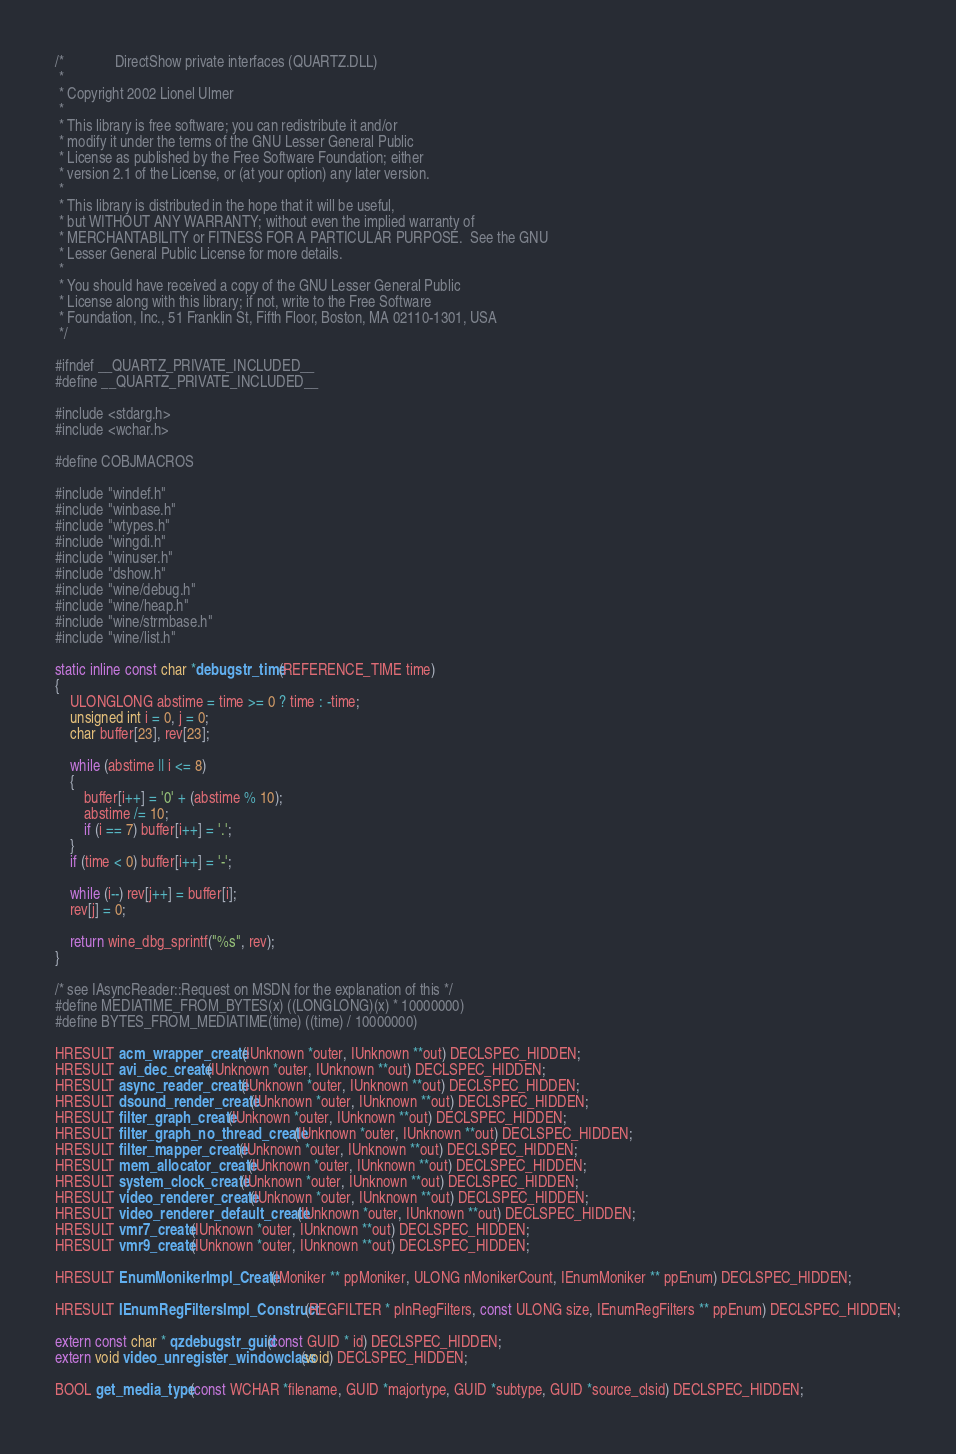Convert code to text. <code><loc_0><loc_0><loc_500><loc_500><_C_>/*              DirectShow private interfaces (QUARTZ.DLL)
 *
 * Copyright 2002 Lionel Ulmer
 *
 * This library is free software; you can redistribute it and/or
 * modify it under the terms of the GNU Lesser General Public
 * License as published by the Free Software Foundation; either
 * version 2.1 of the License, or (at your option) any later version.
 *
 * This library is distributed in the hope that it will be useful,
 * but WITHOUT ANY WARRANTY; without even the implied warranty of
 * MERCHANTABILITY or FITNESS FOR A PARTICULAR PURPOSE.  See the GNU
 * Lesser General Public License for more details.
 *
 * You should have received a copy of the GNU Lesser General Public
 * License along with this library; if not, write to the Free Software
 * Foundation, Inc., 51 Franklin St, Fifth Floor, Boston, MA 02110-1301, USA
 */

#ifndef __QUARTZ_PRIVATE_INCLUDED__
#define __QUARTZ_PRIVATE_INCLUDED__

#include <stdarg.h>
#include <wchar.h>

#define COBJMACROS

#include "windef.h"
#include "winbase.h"
#include "wtypes.h"
#include "wingdi.h"
#include "winuser.h"
#include "dshow.h"
#include "wine/debug.h"
#include "wine/heap.h"
#include "wine/strmbase.h"
#include "wine/list.h"

static inline const char *debugstr_time(REFERENCE_TIME time)
{
    ULONGLONG abstime = time >= 0 ? time : -time;
    unsigned int i = 0, j = 0;
    char buffer[23], rev[23];

    while (abstime || i <= 8)
    {
        buffer[i++] = '0' + (abstime % 10);
        abstime /= 10;
        if (i == 7) buffer[i++] = '.';
    }
    if (time < 0) buffer[i++] = '-';

    while (i--) rev[j++] = buffer[i];
    rev[j] = 0;

    return wine_dbg_sprintf("%s", rev);
}

/* see IAsyncReader::Request on MSDN for the explanation of this */
#define MEDIATIME_FROM_BYTES(x) ((LONGLONG)(x) * 10000000)
#define BYTES_FROM_MEDIATIME(time) ((time) / 10000000)

HRESULT acm_wrapper_create(IUnknown *outer, IUnknown **out) DECLSPEC_HIDDEN;
HRESULT avi_dec_create(IUnknown *outer, IUnknown **out) DECLSPEC_HIDDEN;
HRESULT async_reader_create(IUnknown *outer, IUnknown **out) DECLSPEC_HIDDEN;
HRESULT dsound_render_create(IUnknown *outer, IUnknown **out) DECLSPEC_HIDDEN;
HRESULT filter_graph_create(IUnknown *outer, IUnknown **out) DECLSPEC_HIDDEN;
HRESULT filter_graph_no_thread_create(IUnknown *outer, IUnknown **out) DECLSPEC_HIDDEN;
HRESULT filter_mapper_create(IUnknown *outer, IUnknown **out) DECLSPEC_HIDDEN;
HRESULT mem_allocator_create(IUnknown *outer, IUnknown **out) DECLSPEC_HIDDEN;
HRESULT system_clock_create(IUnknown *outer, IUnknown **out) DECLSPEC_HIDDEN;
HRESULT video_renderer_create(IUnknown *outer, IUnknown **out) DECLSPEC_HIDDEN;
HRESULT video_renderer_default_create(IUnknown *outer, IUnknown **out) DECLSPEC_HIDDEN;
HRESULT vmr7_create(IUnknown *outer, IUnknown **out) DECLSPEC_HIDDEN;
HRESULT vmr9_create(IUnknown *outer, IUnknown **out) DECLSPEC_HIDDEN;

HRESULT EnumMonikerImpl_Create(IMoniker ** ppMoniker, ULONG nMonikerCount, IEnumMoniker ** ppEnum) DECLSPEC_HIDDEN;

HRESULT IEnumRegFiltersImpl_Construct(REGFILTER * pInRegFilters, const ULONG size, IEnumRegFilters ** ppEnum) DECLSPEC_HIDDEN;

extern const char * qzdebugstr_guid(const GUID * id) DECLSPEC_HIDDEN;
extern void video_unregister_windowclass(void) DECLSPEC_HIDDEN;

BOOL get_media_type(const WCHAR *filename, GUID *majortype, GUID *subtype, GUID *source_clsid) DECLSPEC_HIDDEN;
</code> 